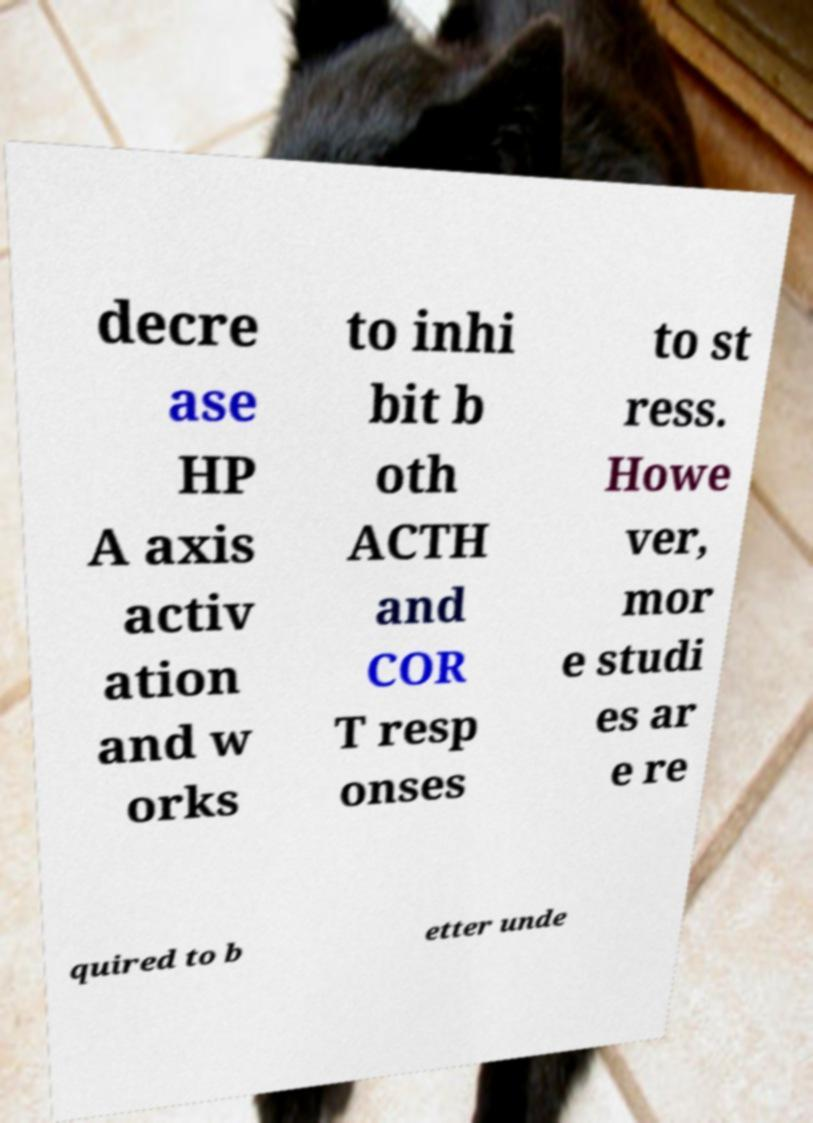Could you assist in decoding the text presented in this image and type it out clearly? decre ase HP A axis activ ation and w orks to inhi bit b oth ACTH and COR T resp onses to st ress. Howe ver, mor e studi es ar e re quired to b etter unde 